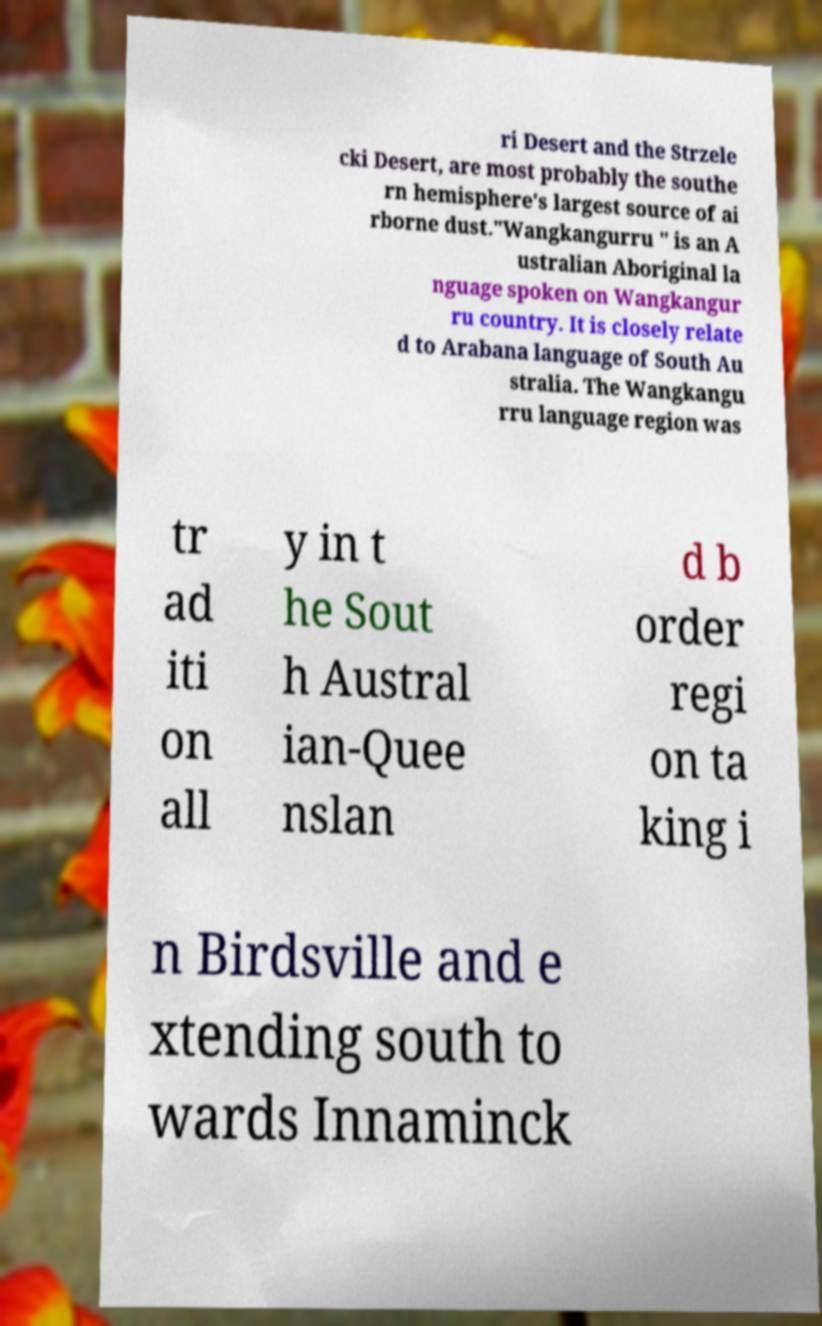For documentation purposes, I need the text within this image transcribed. Could you provide that? ri Desert and the Strzele cki Desert, are most probably the southe rn hemisphere's largest source of ai rborne dust."Wangkangurru " is an A ustralian Aboriginal la nguage spoken on Wangkangur ru country. It is closely relate d to Arabana language of South Au stralia. The Wangkangu rru language region was tr ad iti on all y in t he Sout h Austral ian-Quee nslan d b order regi on ta king i n Birdsville and e xtending south to wards Innaminck 